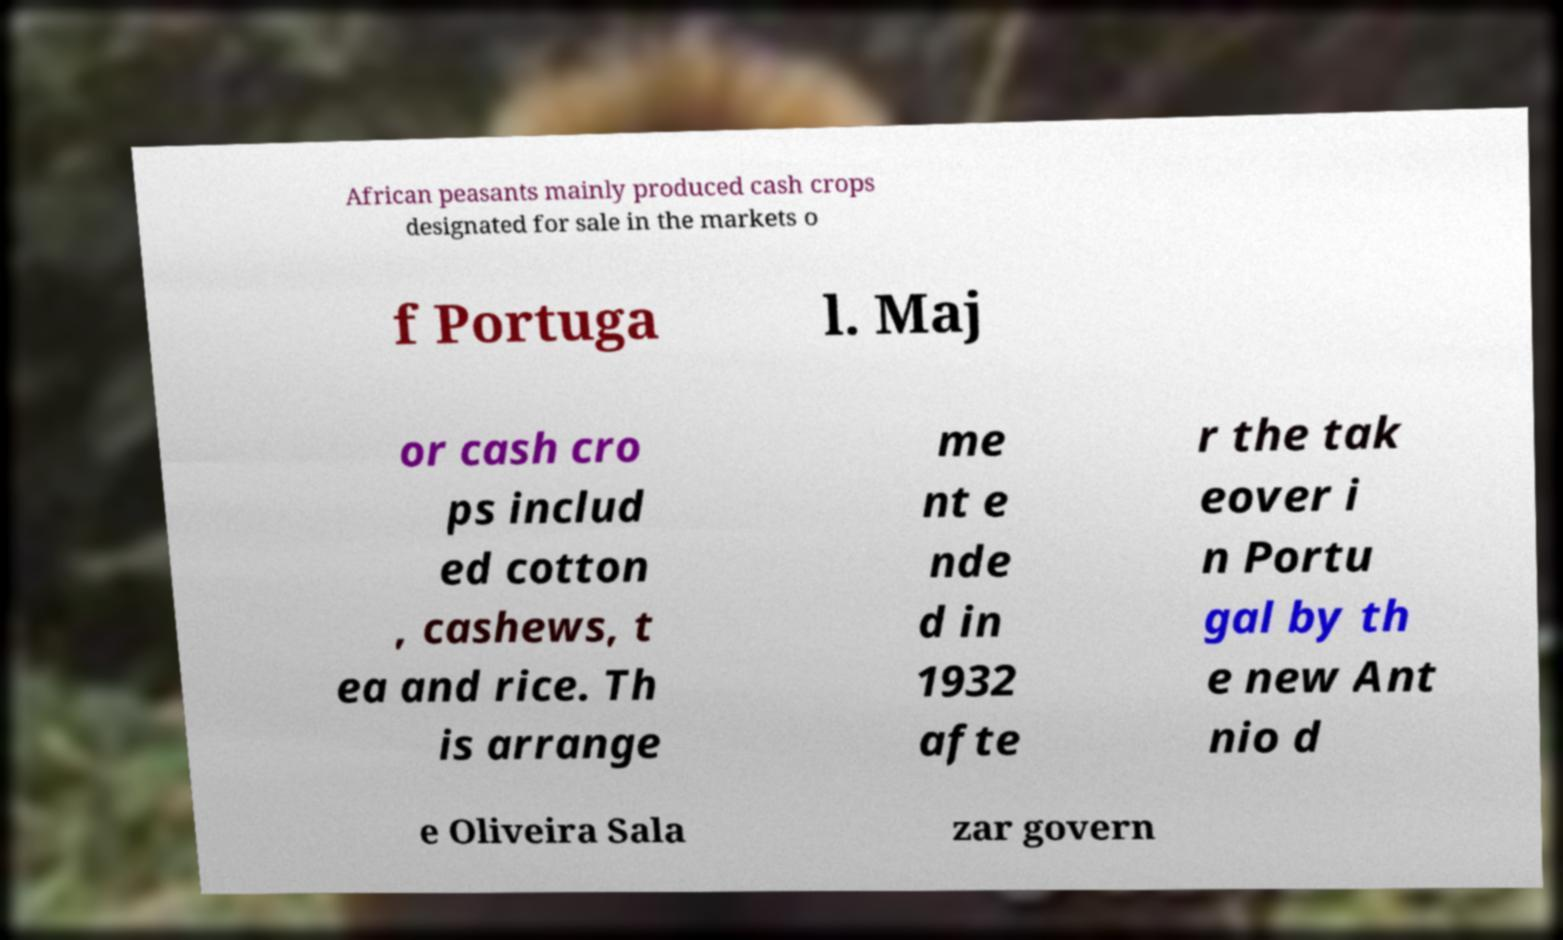Can you accurately transcribe the text from the provided image for me? African peasants mainly produced cash crops designated for sale in the markets o f Portuga l. Maj or cash cro ps includ ed cotton , cashews, t ea and rice. Th is arrange me nt e nde d in 1932 afte r the tak eover i n Portu gal by th e new Ant nio d e Oliveira Sala zar govern 